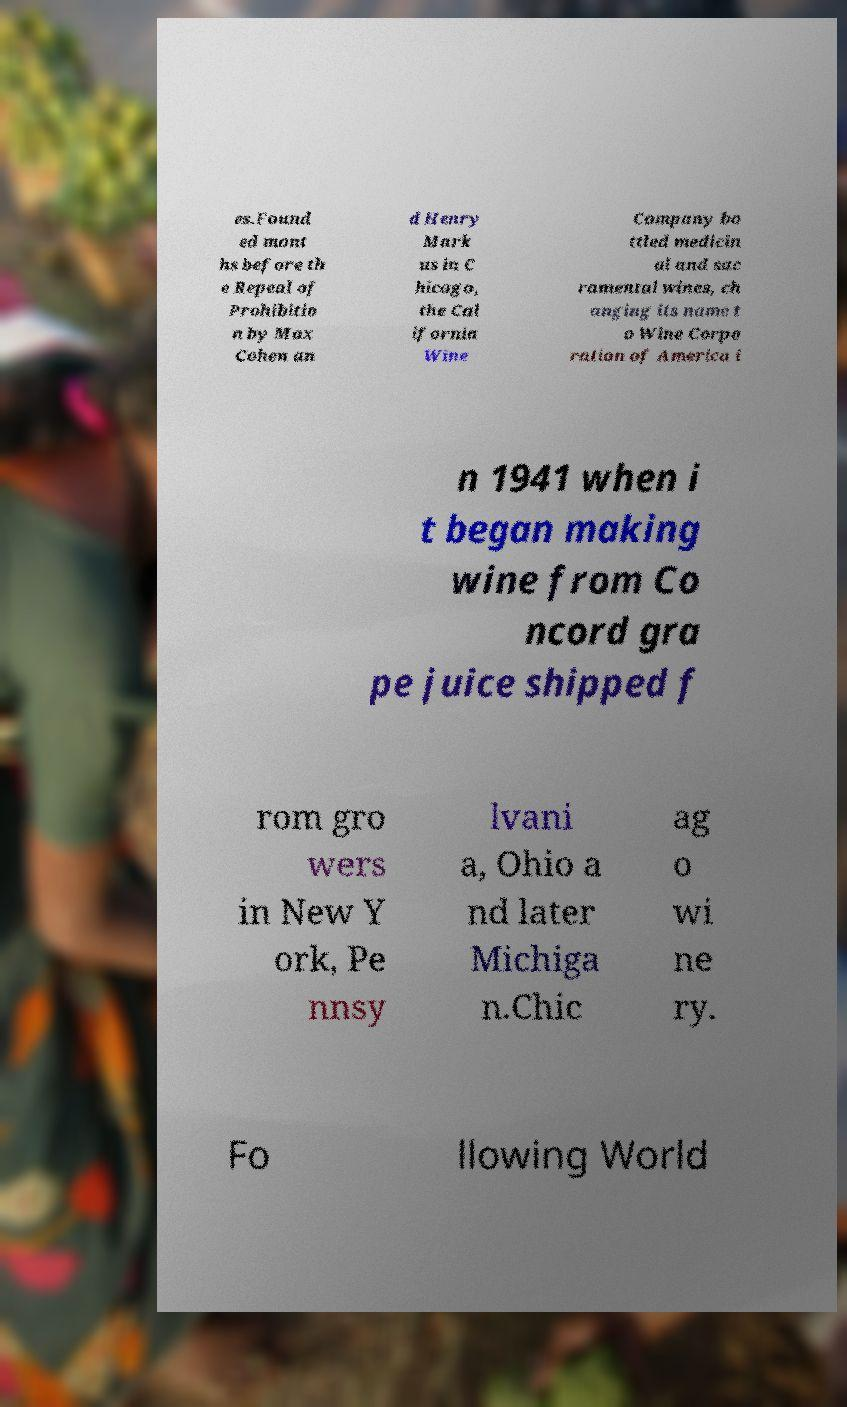There's text embedded in this image that I need extracted. Can you transcribe it verbatim? es.Found ed mont hs before th e Repeal of Prohibitio n by Max Cohen an d Henry Mark us in C hicago, the Cal ifornia Wine Company bo ttled medicin al and sac ramental wines, ch anging its name t o Wine Corpo ration of America i n 1941 when i t began making wine from Co ncord gra pe juice shipped f rom gro wers in New Y ork, Pe nnsy lvani a, Ohio a nd later Michiga n.Chic ag o wi ne ry. Fo llowing World 